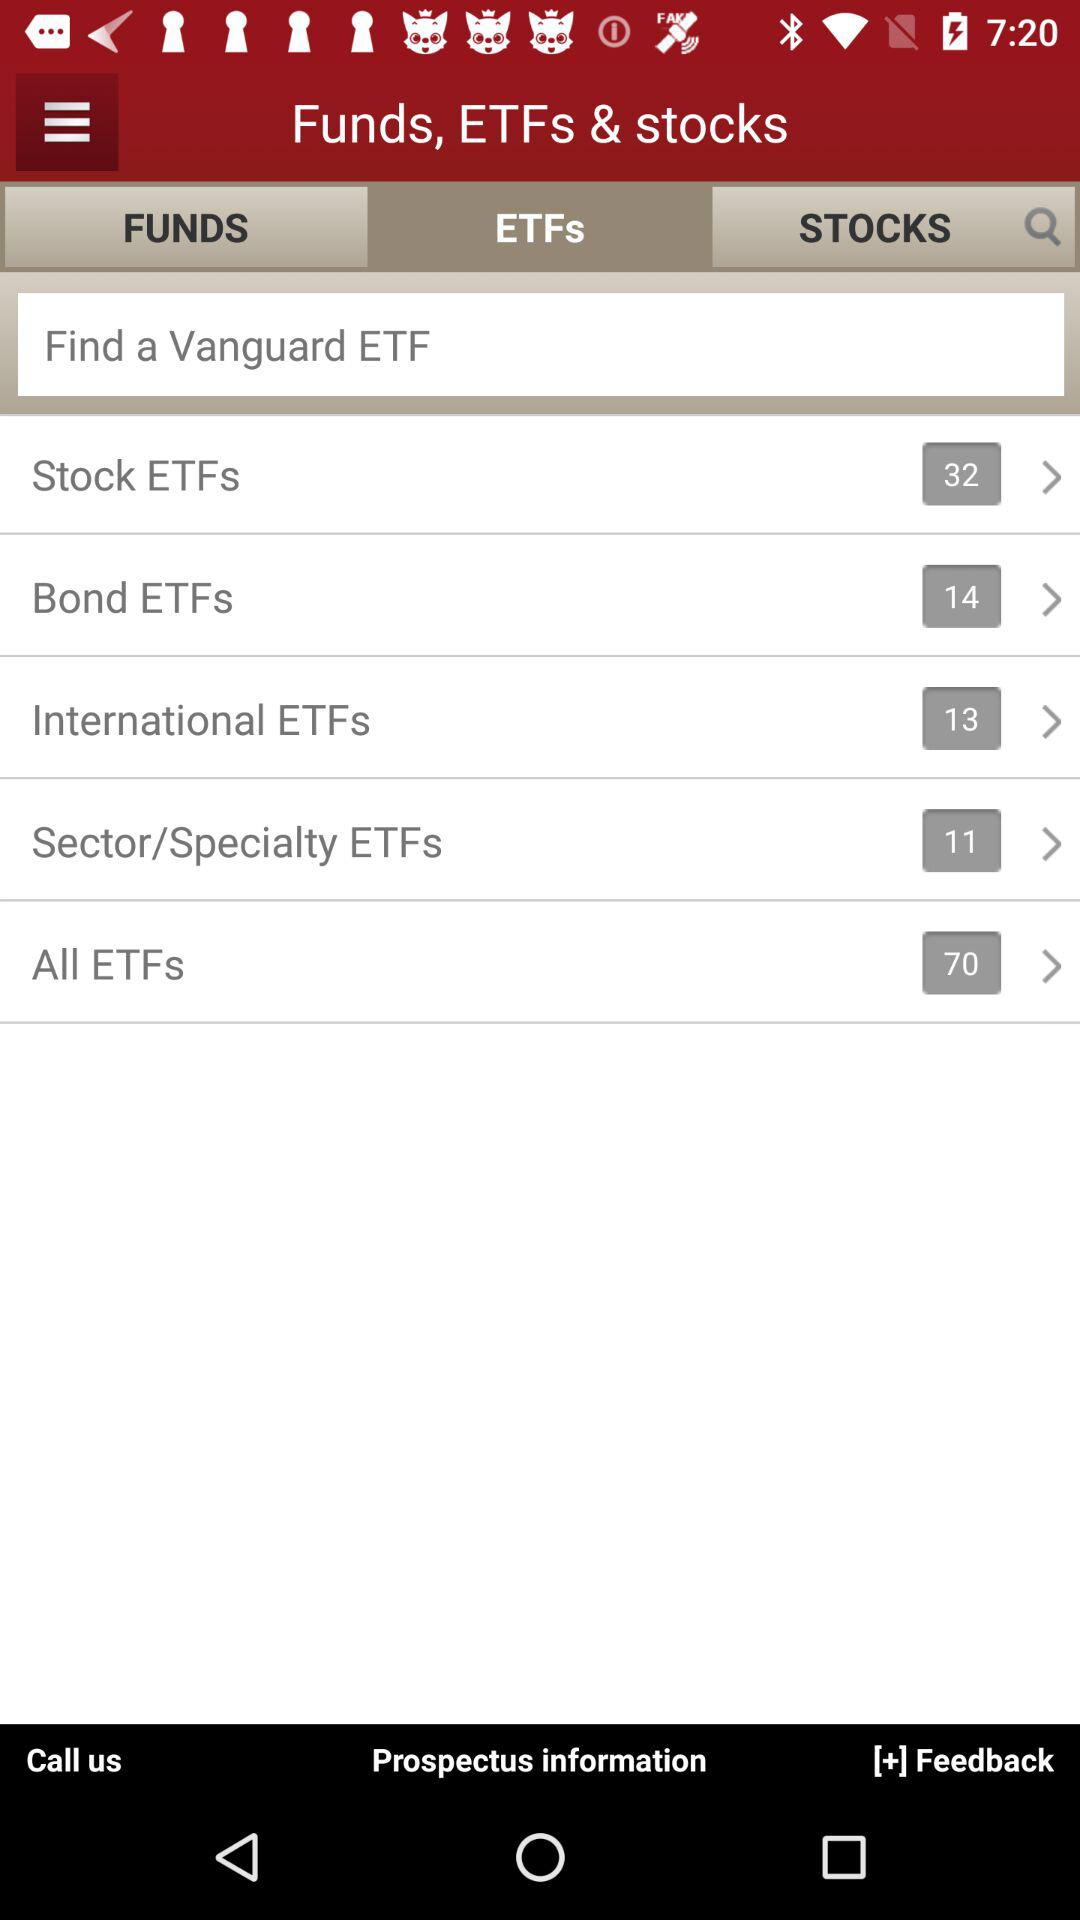How many ETF categories are there?
Answer the question using a single word or phrase. 5 